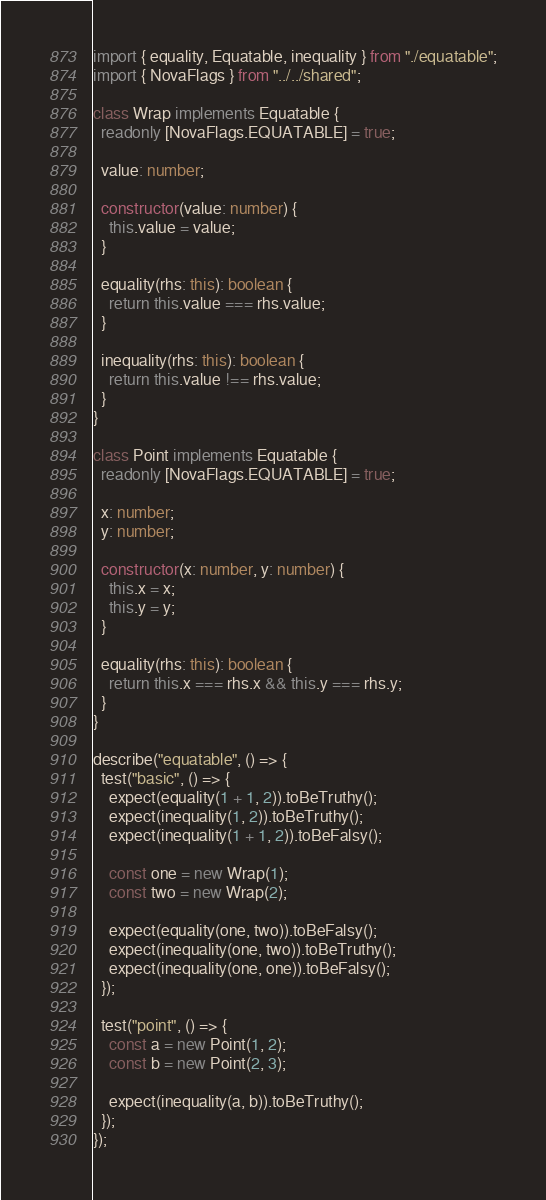Convert code to text. <code><loc_0><loc_0><loc_500><loc_500><_TypeScript_>import { equality, Equatable, inequality } from "./equatable";
import { NovaFlags } from "../../shared";

class Wrap implements Equatable {
  readonly [NovaFlags.EQUATABLE] = true;

  value: number;

  constructor(value: number) {
    this.value = value;
  }

  equality(rhs: this): boolean {
    return this.value === rhs.value;
  }

  inequality(rhs: this): boolean {
    return this.value !== rhs.value;
  }
}

class Point implements Equatable {
  readonly [NovaFlags.EQUATABLE] = true;

  x: number;
  y: number;

  constructor(x: number, y: number) {
    this.x = x;
    this.y = y;
  }

  equality(rhs: this): boolean {
    return this.x === rhs.x && this.y === rhs.y;
  }
}

describe("equatable", () => {
  test("basic", () => {
    expect(equality(1 + 1, 2)).toBeTruthy();
    expect(inequality(1, 2)).toBeTruthy();
    expect(inequality(1 + 1, 2)).toBeFalsy();

    const one = new Wrap(1);
    const two = new Wrap(2);

    expect(equality(one, two)).toBeFalsy();
    expect(inequality(one, two)).toBeTruthy();
    expect(inequality(one, one)).toBeFalsy();
  });

  test("point", () => {
    const a = new Point(1, 2);
    const b = new Point(2, 3);

    expect(inequality(a, b)).toBeTruthy();
  });
});
</code> 